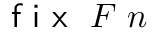<formula> <loc_0><loc_0><loc_500><loc_500>{ f i x } \ F \ n</formula> 